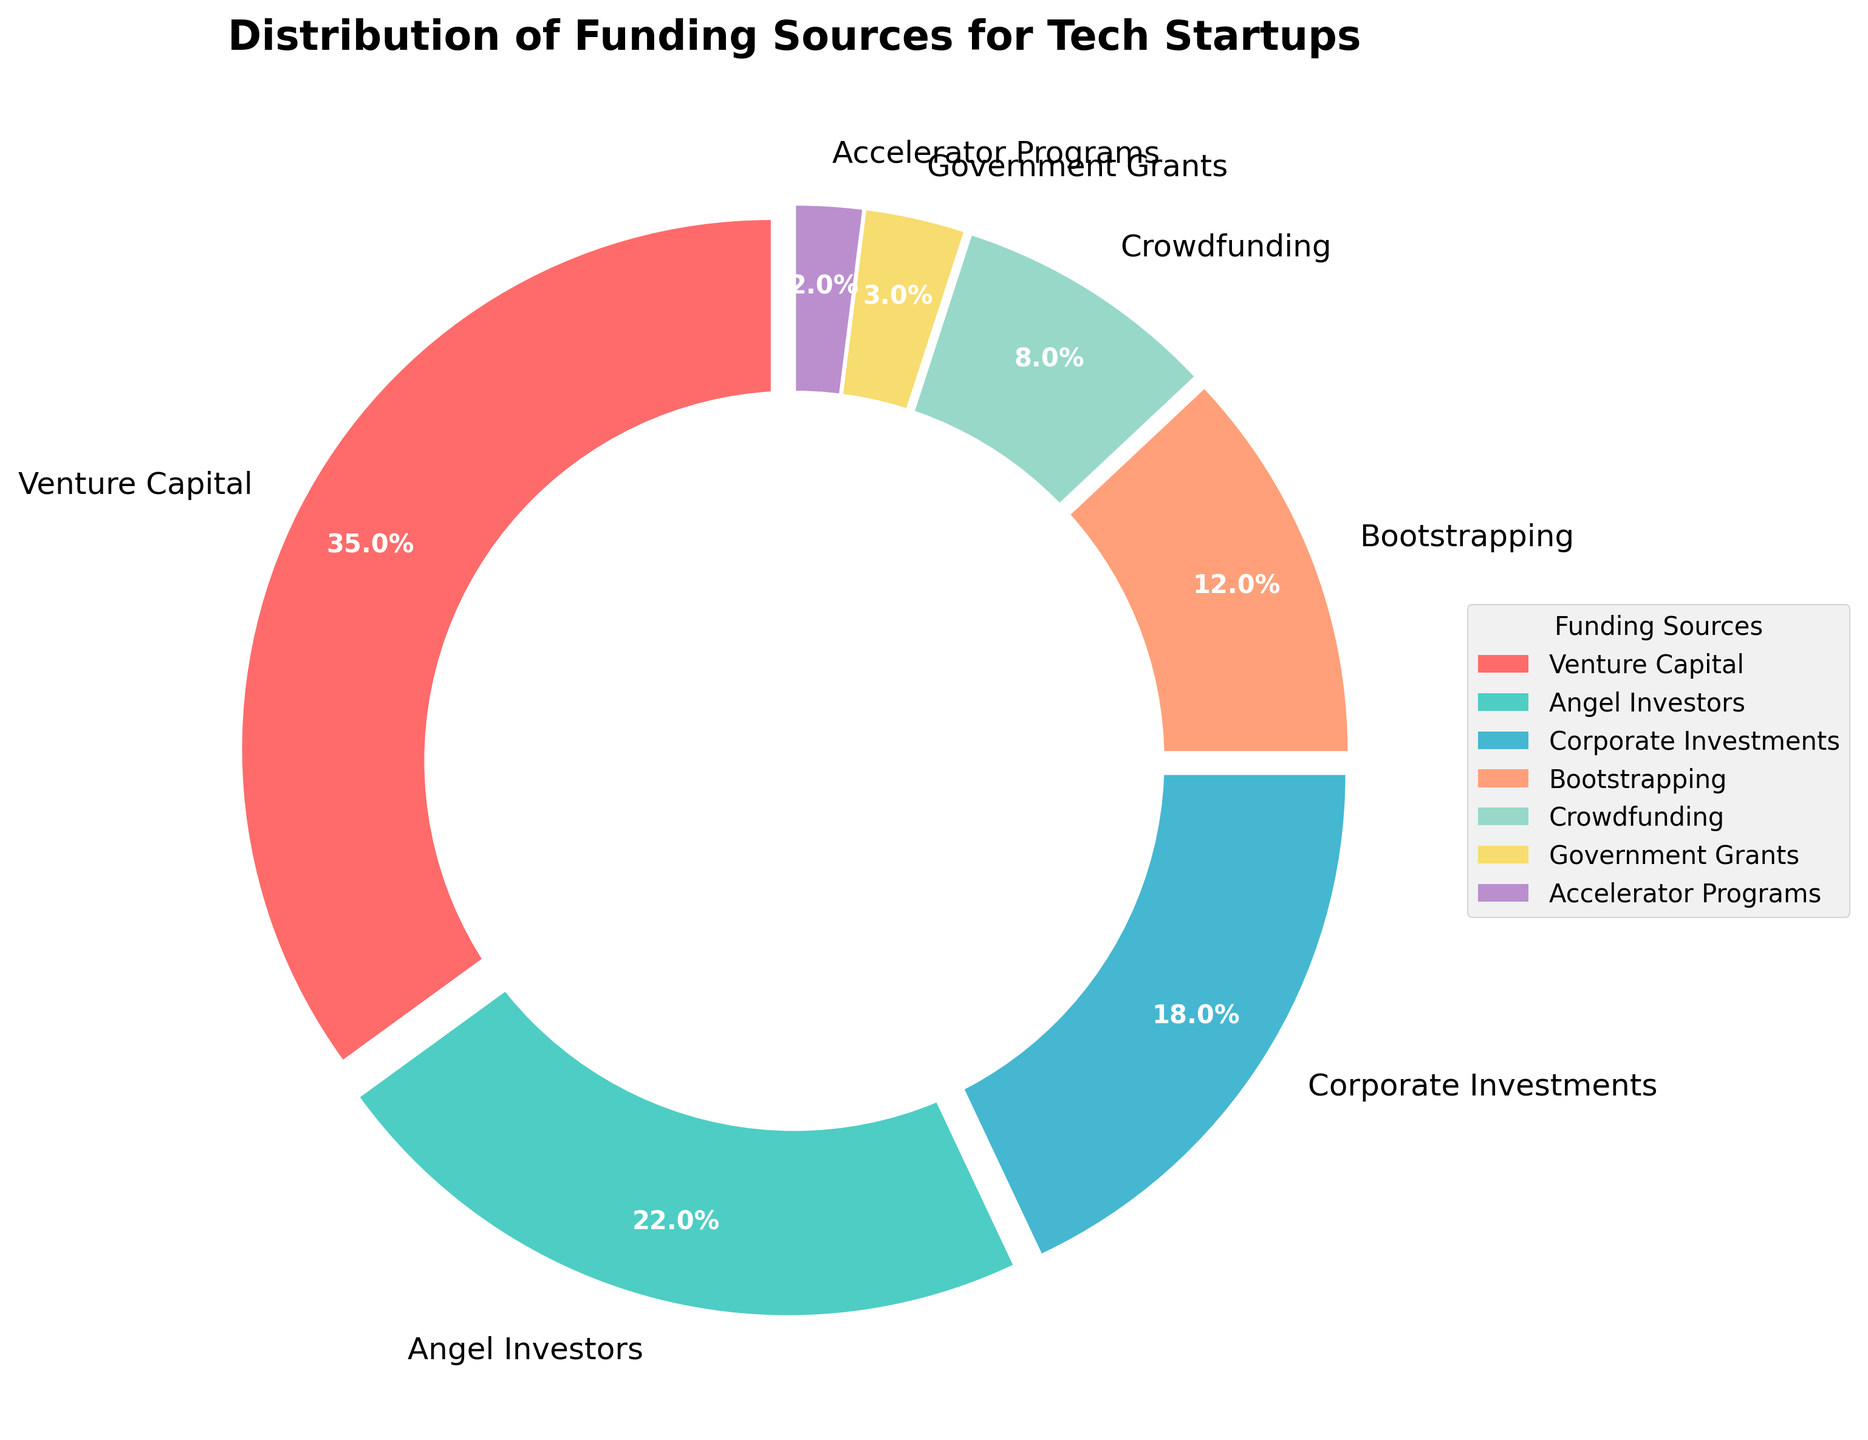Which funding source has the highest percentage? The largest portion of the pie chart will correspond to the funding source with the highest percentage. The data shows that Venture Capital has the largest share with 35%.
Answer: Venture Capital What is the difference in percentage between Venture Capital and Angel Investors? To find the difference, subtract the percentage of Angel Investors from the percentage of Venture Capital. 35 (Venture Capital) - 22 (Angel Investors) = 13.
Answer: 13 What is the combined percentage of Corporate Investments and Crowdfunding? Add the percentages of Corporate Investments and Crowdfunding. 18 (Corporate Investments) + 8 (Crowdfunding) = 26.
Answer: 26 Which funding source has the smallest percentage? The smallest portion of the pie chart will indicate the funding source with the lowest percentage. According to the data, Accelerator Programs have the smallest share with 2%.
Answer: Accelerator Programs How many funding sources contribute more than 10% each? Identify the funding sources with a percentage greater than 10 and count them. Venture Capital (35%), Angel Investors (22%), and Corporate Investments (18%) qualify, making it a total of 3.
Answer: 3 Are Bootstrapping and Crowdfunding together contributing more or less than Angel Investors? Sum the percentages of Bootstrapping and Crowdfunding and compare with the percentage of Angel Investors. 12 (Bootstrapping) + 8 (Crowdfunding) = 20; Angel Investors have 22%. So, 20 is less than 22.
Answer: Less What is the average percentage contribution of Venture Capital, Angel Investors, and Corporate Investments? To calculate the average, sum the percentages of the three funding sources and divide by the number of sources. (35 + 22 + 18) / 3 = 75 / 3 = 25.
Answer: 25 Is the percentage contributed by Government Grants greater than or equal to the combined percentage of Accelerator Programs and Crowdfunding? First, sum the percentages of Accelerator Programs and Crowdfunding. 2 + 8 = 10. Compare this with the percentage of Government Grants, which is 3. Since 3 is less than 10, the answer is no.
Answer: No Which color represents Bootstrapping in the pie chart? Bootstrapping in the chart is designated with a specific color. Refer to the chart's color depiction. According to the color palette used, Bootstrapping is represented by a shade of orange.
Answer: Orange 